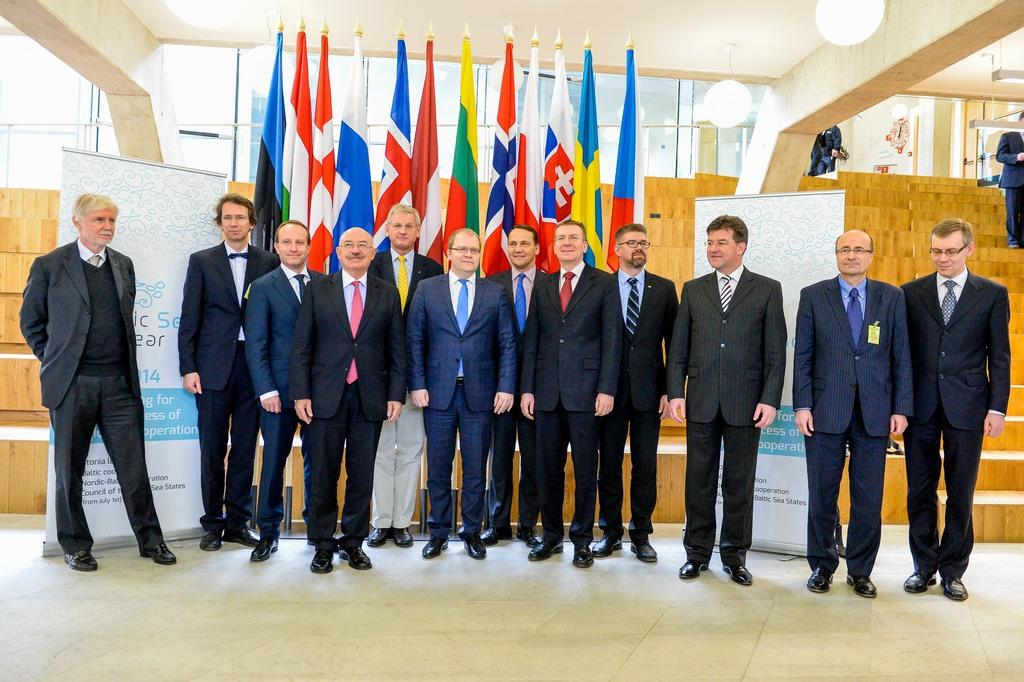What is the main subject of the image? The main subject of the image is a group of people. What can be seen behind the group of people? There are flags behind the group of people. What type of lighting is present in the image? There are lamps hanging from a roof in the image. Can you tell me how many fairies are flying around the group of people in the image? There are no fairies present in the image; it only features a group of people, flags, and lamps. 